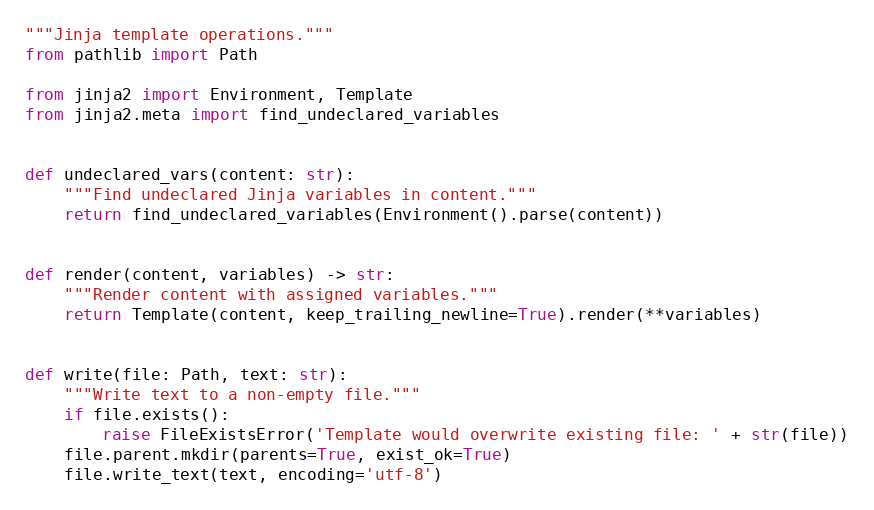<code> <loc_0><loc_0><loc_500><loc_500><_Python_>"""Jinja template operations."""
from pathlib import Path

from jinja2 import Environment, Template
from jinja2.meta import find_undeclared_variables


def undeclared_vars(content: str):
    """Find undeclared Jinja variables in content."""
    return find_undeclared_variables(Environment().parse(content))


def render(content, variables) -> str:
    """Render content with assigned variables."""
    return Template(content, keep_trailing_newline=True).render(**variables)


def write(file: Path, text: str):
    """Write text to a non-empty file."""
    if file.exists():
        raise FileExistsError('Template would overwrite existing file: ' + str(file))
    file.parent.mkdir(parents=True, exist_ok=True)
    file.write_text(text, encoding='utf-8')
</code> 